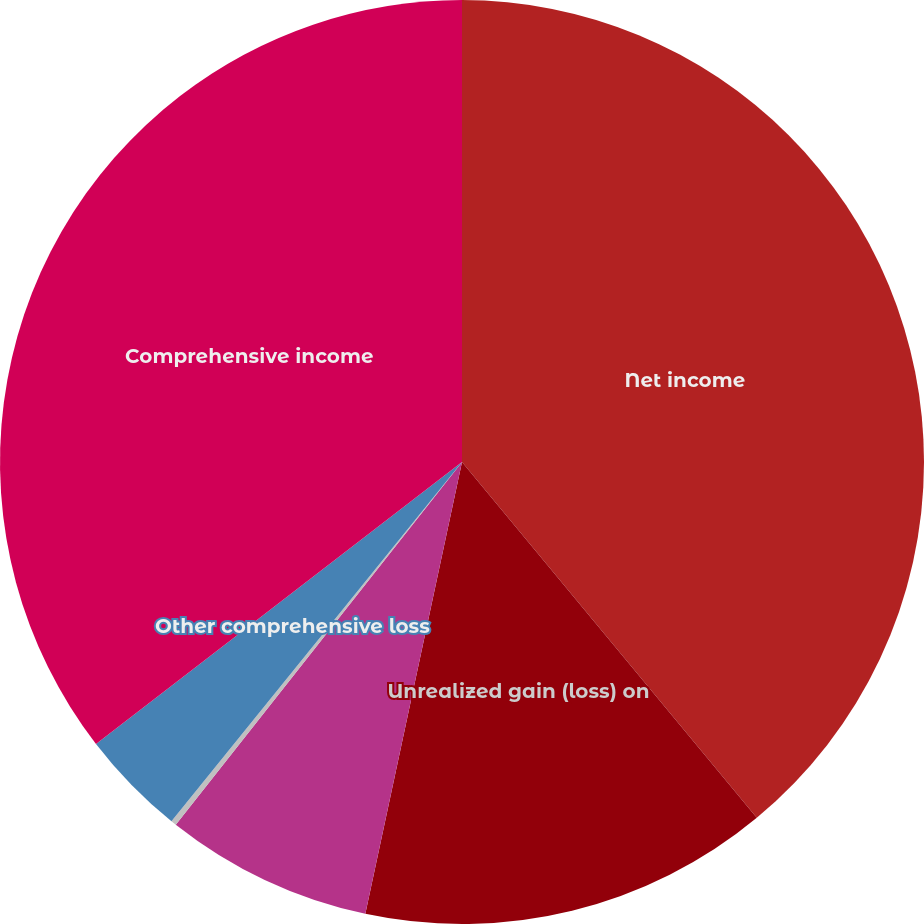Convert chart to OTSL. <chart><loc_0><loc_0><loc_500><loc_500><pie_chart><fcel>Net income<fcel>Unrealized gain (loss) on<fcel>Translation adjustment<fcel>Net change in retirement<fcel>Other comprehensive loss<fcel>Comprehensive income<nl><fcel>38.99%<fcel>14.37%<fcel>7.28%<fcel>0.19%<fcel>3.73%<fcel>35.45%<nl></chart> 